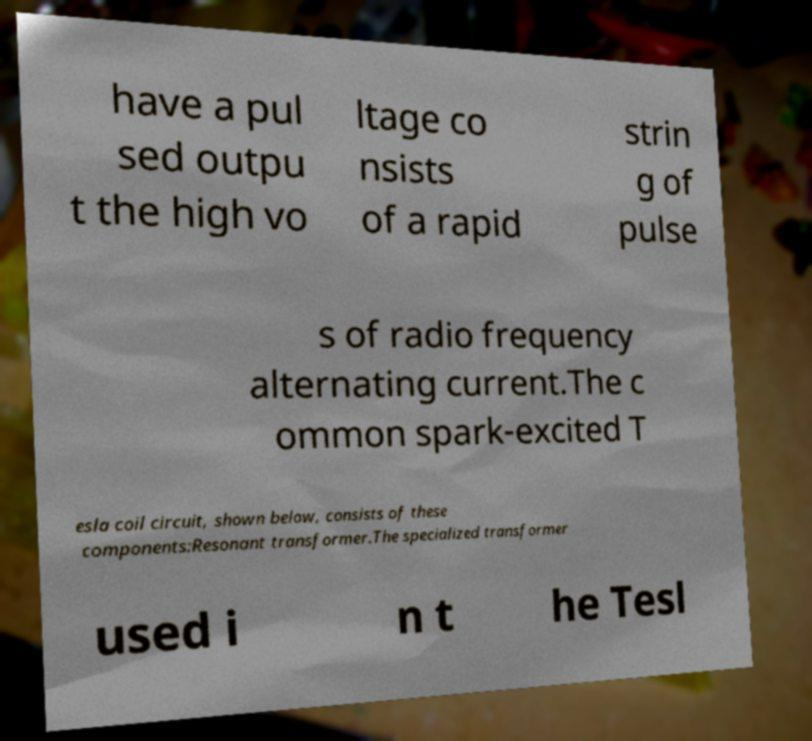Could you assist in decoding the text presented in this image and type it out clearly? have a pul sed outpu t the high vo ltage co nsists of a rapid strin g of pulse s of radio frequency alternating current.The c ommon spark-excited T esla coil circuit, shown below, consists of these components:Resonant transformer.The specialized transformer used i n t he Tesl 